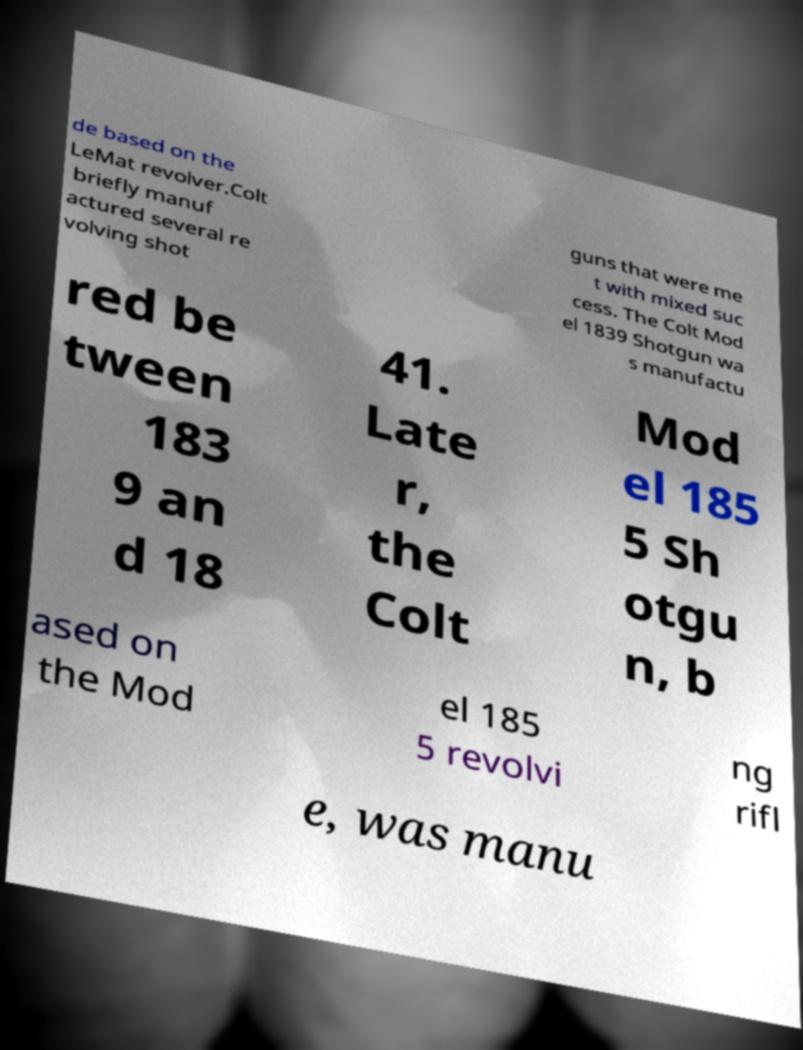Please identify and transcribe the text found in this image. de based on the LeMat revolver.Colt briefly manuf actured several re volving shot guns that were me t with mixed suc cess. The Colt Mod el 1839 Shotgun wa s manufactu red be tween 183 9 an d 18 41. Late r, the Colt Mod el 185 5 Sh otgu n, b ased on the Mod el 185 5 revolvi ng rifl e, was manu 